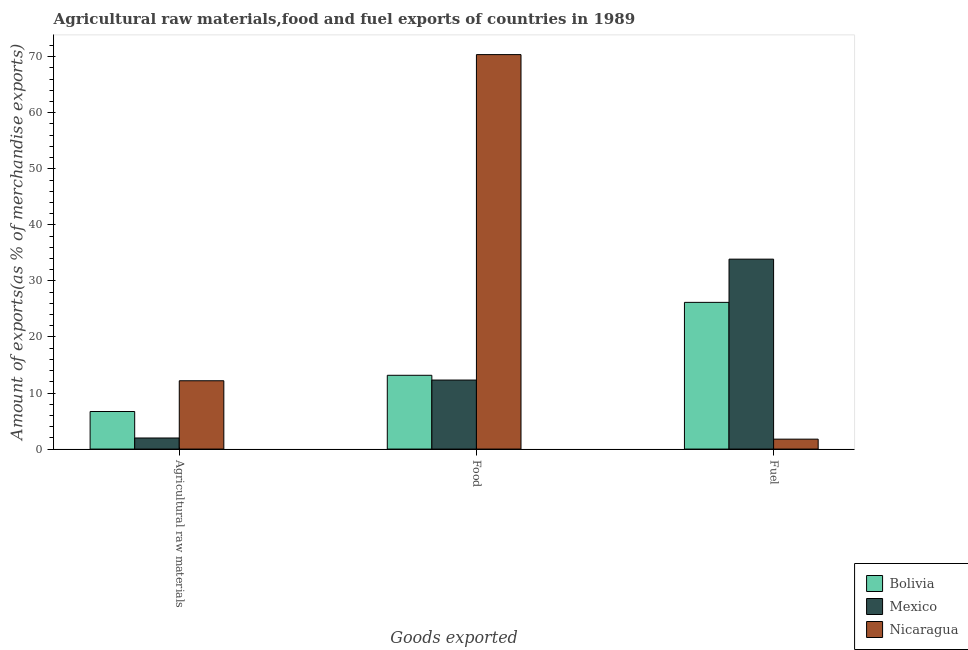How many different coloured bars are there?
Your answer should be compact. 3. How many groups of bars are there?
Keep it short and to the point. 3. How many bars are there on the 1st tick from the left?
Your response must be concise. 3. How many bars are there on the 1st tick from the right?
Your answer should be very brief. 3. What is the label of the 3rd group of bars from the left?
Provide a succinct answer. Fuel. What is the percentage of raw materials exports in Bolivia?
Keep it short and to the point. 6.7. Across all countries, what is the maximum percentage of raw materials exports?
Ensure brevity in your answer.  12.19. Across all countries, what is the minimum percentage of food exports?
Make the answer very short. 12.31. In which country was the percentage of food exports maximum?
Your answer should be very brief. Nicaragua. In which country was the percentage of food exports minimum?
Keep it short and to the point. Mexico. What is the total percentage of raw materials exports in the graph?
Your answer should be compact. 20.87. What is the difference between the percentage of fuel exports in Bolivia and that in Nicaragua?
Offer a terse response. 24.4. What is the difference between the percentage of food exports in Mexico and the percentage of raw materials exports in Nicaragua?
Your answer should be compact. 0.12. What is the average percentage of food exports per country?
Ensure brevity in your answer.  31.95. What is the difference between the percentage of fuel exports and percentage of food exports in Mexico?
Make the answer very short. 21.57. What is the ratio of the percentage of raw materials exports in Mexico to that in Nicaragua?
Keep it short and to the point. 0.16. Is the percentage of fuel exports in Nicaragua less than that in Bolivia?
Ensure brevity in your answer.  Yes. What is the difference between the highest and the second highest percentage of raw materials exports?
Make the answer very short. 5.49. What is the difference between the highest and the lowest percentage of food exports?
Your response must be concise. 58.06. What does the 2nd bar from the right in Food represents?
Make the answer very short. Mexico. Is it the case that in every country, the sum of the percentage of raw materials exports and percentage of food exports is greater than the percentage of fuel exports?
Offer a very short reply. No. How many bars are there?
Ensure brevity in your answer.  9. Are all the bars in the graph horizontal?
Ensure brevity in your answer.  No. What is the difference between two consecutive major ticks on the Y-axis?
Keep it short and to the point. 10. Are the values on the major ticks of Y-axis written in scientific E-notation?
Offer a very short reply. No. Does the graph contain any zero values?
Your answer should be very brief. No. What is the title of the graph?
Provide a succinct answer. Agricultural raw materials,food and fuel exports of countries in 1989. Does "Lithuania" appear as one of the legend labels in the graph?
Your response must be concise. No. What is the label or title of the X-axis?
Your response must be concise. Goods exported. What is the label or title of the Y-axis?
Ensure brevity in your answer.  Amount of exports(as % of merchandise exports). What is the Amount of exports(as % of merchandise exports) in Bolivia in Agricultural raw materials?
Provide a succinct answer. 6.7. What is the Amount of exports(as % of merchandise exports) in Mexico in Agricultural raw materials?
Keep it short and to the point. 1.98. What is the Amount of exports(as % of merchandise exports) in Nicaragua in Agricultural raw materials?
Your answer should be compact. 12.19. What is the Amount of exports(as % of merchandise exports) of Bolivia in Food?
Make the answer very short. 13.16. What is the Amount of exports(as % of merchandise exports) in Mexico in Food?
Your answer should be compact. 12.31. What is the Amount of exports(as % of merchandise exports) in Nicaragua in Food?
Make the answer very short. 70.37. What is the Amount of exports(as % of merchandise exports) in Bolivia in Fuel?
Keep it short and to the point. 26.17. What is the Amount of exports(as % of merchandise exports) in Mexico in Fuel?
Your answer should be compact. 33.88. What is the Amount of exports(as % of merchandise exports) of Nicaragua in Fuel?
Ensure brevity in your answer.  1.77. Across all Goods exported, what is the maximum Amount of exports(as % of merchandise exports) in Bolivia?
Offer a very short reply. 26.17. Across all Goods exported, what is the maximum Amount of exports(as % of merchandise exports) of Mexico?
Offer a terse response. 33.88. Across all Goods exported, what is the maximum Amount of exports(as % of merchandise exports) in Nicaragua?
Offer a terse response. 70.37. Across all Goods exported, what is the minimum Amount of exports(as % of merchandise exports) in Bolivia?
Ensure brevity in your answer.  6.7. Across all Goods exported, what is the minimum Amount of exports(as % of merchandise exports) of Mexico?
Provide a succinct answer. 1.98. Across all Goods exported, what is the minimum Amount of exports(as % of merchandise exports) of Nicaragua?
Ensure brevity in your answer.  1.77. What is the total Amount of exports(as % of merchandise exports) in Bolivia in the graph?
Keep it short and to the point. 46.04. What is the total Amount of exports(as % of merchandise exports) of Mexico in the graph?
Ensure brevity in your answer.  48.17. What is the total Amount of exports(as % of merchandise exports) in Nicaragua in the graph?
Offer a terse response. 84.33. What is the difference between the Amount of exports(as % of merchandise exports) in Bolivia in Agricultural raw materials and that in Food?
Provide a short and direct response. -6.46. What is the difference between the Amount of exports(as % of merchandise exports) in Mexico in Agricultural raw materials and that in Food?
Your answer should be very brief. -10.34. What is the difference between the Amount of exports(as % of merchandise exports) of Nicaragua in Agricultural raw materials and that in Food?
Provide a short and direct response. -58.18. What is the difference between the Amount of exports(as % of merchandise exports) of Bolivia in Agricultural raw materials and that in Fuel?
Your answer should be very brief. -19.47. What is the difference between the Amount of exports(as % of merchandise exports) of Mexico in Agricultural raw materials and that in Fuel?
Keep it short and to the point. -31.9. What is the difference between the Amount of exports(as % of merchandise exports) in Nicaragua in Agricultural raw materials and that in Fuel?
Ensure brevity in your answer.  10.42. What is the difference between the Amount of exports(as % of merchandise exports) in Bolivia in Food and that in Fuel?
Provide a short and direct response. -13.01. What is the difference between the Amount of exports(as % of merchandise exports) of Mexico in Food and that in Fuel?
Ensure brevity in your answer.  -21.57. What is the difference between the Amount of exports(as % of merchandise exports) in Nicaragua in Food and that in Fuel?
Provide a succinct answer. 68.6. What is the difference between the Amount of exports(as % of merchandise exports) of Bolivia in Agricultural raw materials and the Amount of exports(as % of merchandise exports) of Mexico in Food?
Give a very brief answer. -5.61. What is the difference between the Amount of exports(as % of merchandise exports) of Bolivia in Agricultural raw materials and the Amount of exports(as % of merchandise exports) of Nicaragua in Food?
Give a very brief answer. -63.67. What is the difference between the Amount of exports(as % of merchandise exports) of Mexico in Agricultural raw materials and the Amount of exports(as % of merchandise exports) of Nicaragua in Food?
Offer a very short reply. -68.39. What is the difference between the Amount of exports(as % of merchandise exports) of Bolivia in Agricultural raw materials and the Amount of exports(as % of merchandise exports) of Mexico in Fuel?
Keep it short and to the point. -27.18. What is the difference between the Amount of exports(as % of merchandise exports) in Bolivia in Agricultural raw materials and the Amount of exports(as % of merchandise exports) in Nicaragua in Fuel?
Offer a terse response. 4.93. What is the difference between the Amount of exports(as % of merchandise exports) in Mexico in Agricultural raw materials and the Amount of exports(as % of merchandise exports) in Nicaragua in Fuel?
Offer a terse response. 0.21. What is the difference between the Amount of exports(as % of merchandise exports) in Bolivia in Food and the Amount of exports(as % of merchandise exports) in Mexico in Fuel?
Your response must be concise. -20.72. What is the difference between the Amount of exports(as % of merchandise exports) of Bolivia in Food and the Amount of exports(as % of merchandise exports) of Nicaragua in Fuel?
Give a very brief answer. 11.39. What is the difference between the Amount of exports(as % of merchandise exports) in Mexico in Food and the Amount of exports(as % of merchandise exports) in Nicaragua in Fuel?
Give a very brief answer. 10.54. What is the average Amount of exports(as % of merchandise exports) of Bolivia per Goods exported?
Your response must be concise. 15.35. What is the average Amount of exports(as % of merchandise exports) in Mexico per Goods exported?
Give a very brief answer. 16.06. What is the average Amount of exports(as % of merchandise exports) of Nicaragua per Goods exported?
Make the answer very short. 28.11. What is the difference between the Amount of exports(as % of merchandise exports) of Bolivia and Amount of exports(as % of merchandise exports) of Mexico in Agricultural raw materials?
Offer a terse response. 4.72. What is the difference between the Amount of exports(as % of merchandise exports) in Bolivia and Amount of exports(as % of merchandise exports) in Nicaragua in Agricultural raw materials?
Provide a short and direct response. -5.49. What is the difference between the Amount of exports(as % of merchandise exports) in Mexico and Amount of exports(as % of merchandise exports) in Nicaragua in Agricultural raw materials?
Provide a succinct answer. -10.21. What is the difference between the Amount of exports(as % of merchandise exports) of Bolivia and Amount of exports(as % of merchandise exports) of Mexico in Food?
Your answer should be very brief. 0.85. What is the difference between the Amount of exports(as % of merchandise exports) of Bolivia and Amount of exports(as % of merchandise exports) of Nicaragua in Food?
Give a very brief answer. -57.21. What is the difference between the Amount of exports(as % of merchandise exports) of Mexico and Amount of exports(as % of merchandise exports) of Nicaragua in Food?
Offer a terse response. -58.06. What is the difference between the Amount of exports(as % of merchandise exports) of Bolivia and Amount of exports(as % of merchandise exports) of Mexico in Fuel?
Your response must be concise. -7.71. What is the difference between the Amount of exports(as % of merchandise exports) in Bolivia and Amount of exports(as % of merchandise exports) in Nicaragua in Fuel?
Ensure brevity in your answer.  24.4. What is the difference between the Amount of exports(as % of merchandise exports) in Mexico and Amount of exports(as % of merchandise exports) in Nicaragua in Fuel?
Offer a terse response. 32.11. What is the ratio of the Amount of exports(as % of merchandise exports) in Bolivia in Agricultural raw materials to that in Food?
Provide a short and direct response. 0.51. What is the ratio of the Amount of exports(as % of merchandise exports) of Mexico in Agricultural raw materials to that in Food?
Offer a very short reply. 0.16. What is the ratio of the Amount of exports(as % of merchandise exports) in Nicaragua in Agricultural raw materials to that in Food?
Offer a terse response. 0.17. What is the ratio of the Amount of exports(as % of merchandise exports) of Bolivia in Agricultural raw materials to that in Fuel?
Keep it short and to the point. 0.26. What is the ratio of the Amount of exports(as % of merchandise exports) in Mexico in Agricultural raw materials to that in Fuel?
Ensure brevity in your answer.  0.06. What is the ratio of the Amount of exports(as % of merchandise exports) of Nicaragua in Agricultural raw materials to that in Fuel?
Make the answer very short. 6.88. What is the ratio of the Amount of exports(as % of merchandise exports) in Bolivia in Food to that in Fuel?
Offer a very short reply. 0.5. What is the ratio of the Amount of exports(as % of merchandise exports) of Mexico in Food to that in Fuel?
Offer a very short reply. 0.36. What is the ratio of the Amount of exports(as % of merchandise exports) of Nicaragua in Food to that in Fuel?
Provide a short and direct response. 39.73. What is the difference between the highest and the second highest Amount of exports(as % of merchandise exports) in Bolivia?
Offer a terse response. 13.01. What is the difference between the highest and the second highest Amount of exports(as % of merchandise exports) of Mexico?
Provide a short and direct response. 21.57. What is the difference between the highest and the second highest Amount of exports(as % of merchandise exports) of Nicaragua?
Provide a short and direct response. 58.18. What is the difference between the highest and the lowest Amount of exports(as % of merchandise exports) in Bolivia?
Your answer should be very brief. 19.47. What is the difference between the highest and the lowest Amount of exports(as % of merchandise exports) of Mexico?
Your answer should be very brief. 31.9. What is the difference between the highest and the lowest Amount of exports(as % of merchandise exports) in Nicaragua?
Provide a succinct answer. 68.6. 